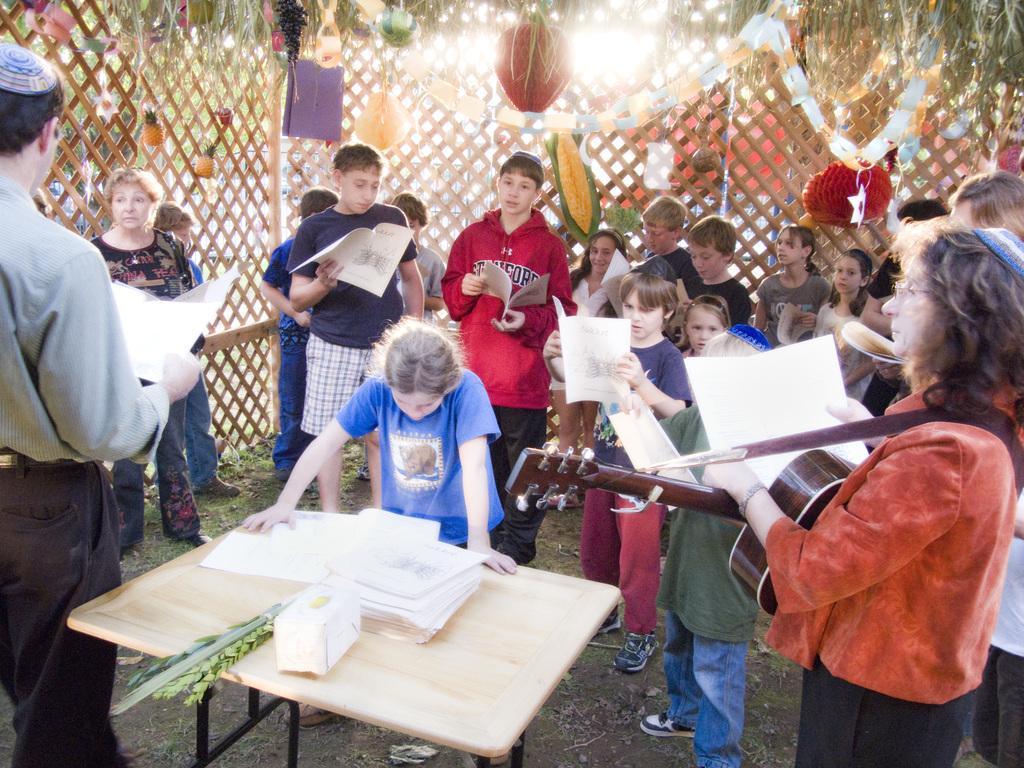Can you describe this image briefly? There are group of people standing and holding book in their hand. Here in the middle there is a girl placed her hands on the table and looking at the book. In the background we can see fruits hanging. 